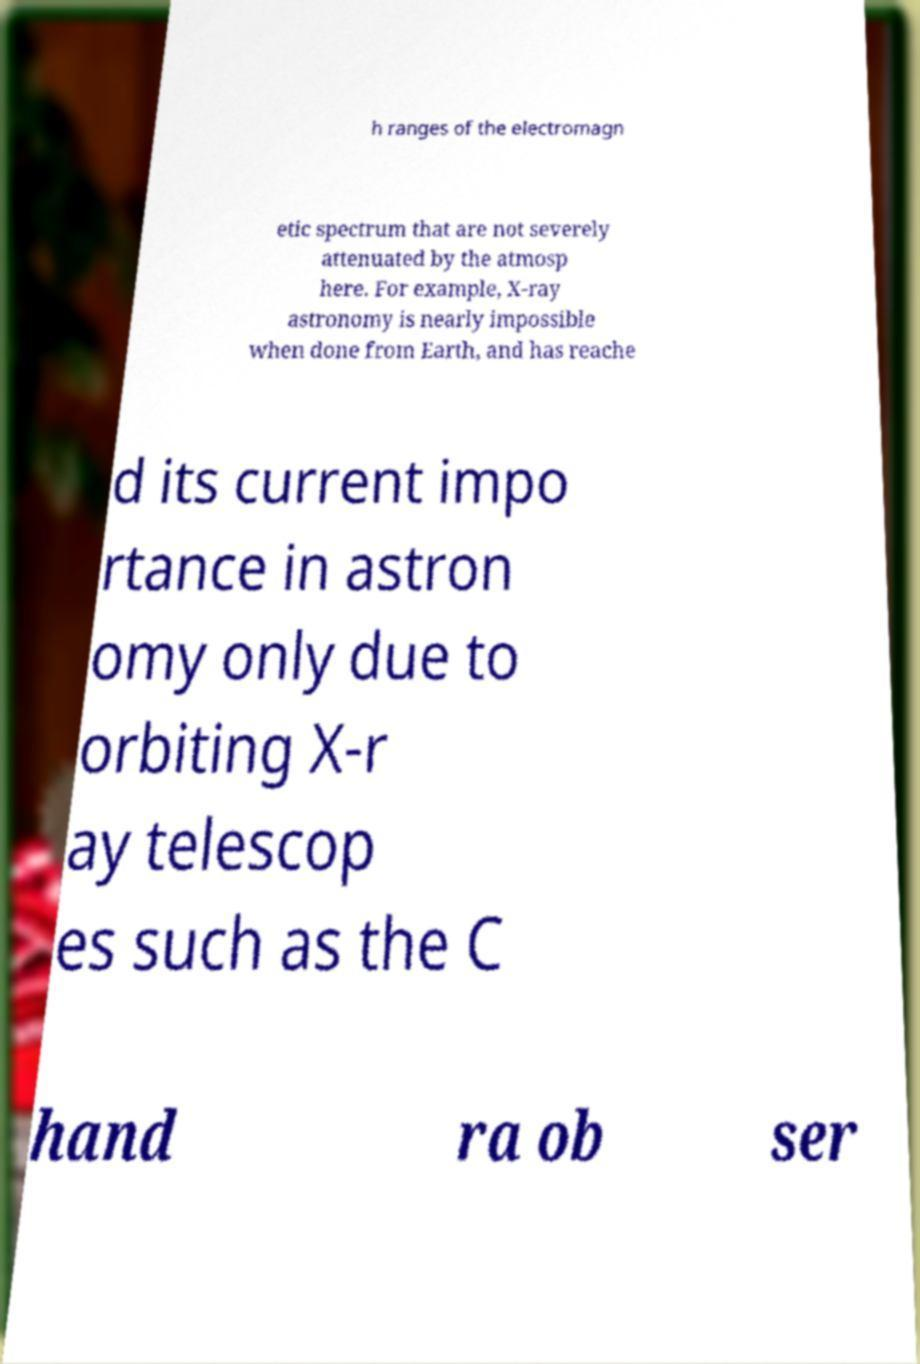Could you assist in decoding the text presented in this image and type it out clearly? h ranges of the electromagn etic spectrum that are not severely attenuated by the atmosp here. For example, X-ray astronomy is nearly impossible when done from Earth, and has reache d its current impo rtance in astron omy only due to orbiting X-r ay telescop es such as the C hand ra ob ser 